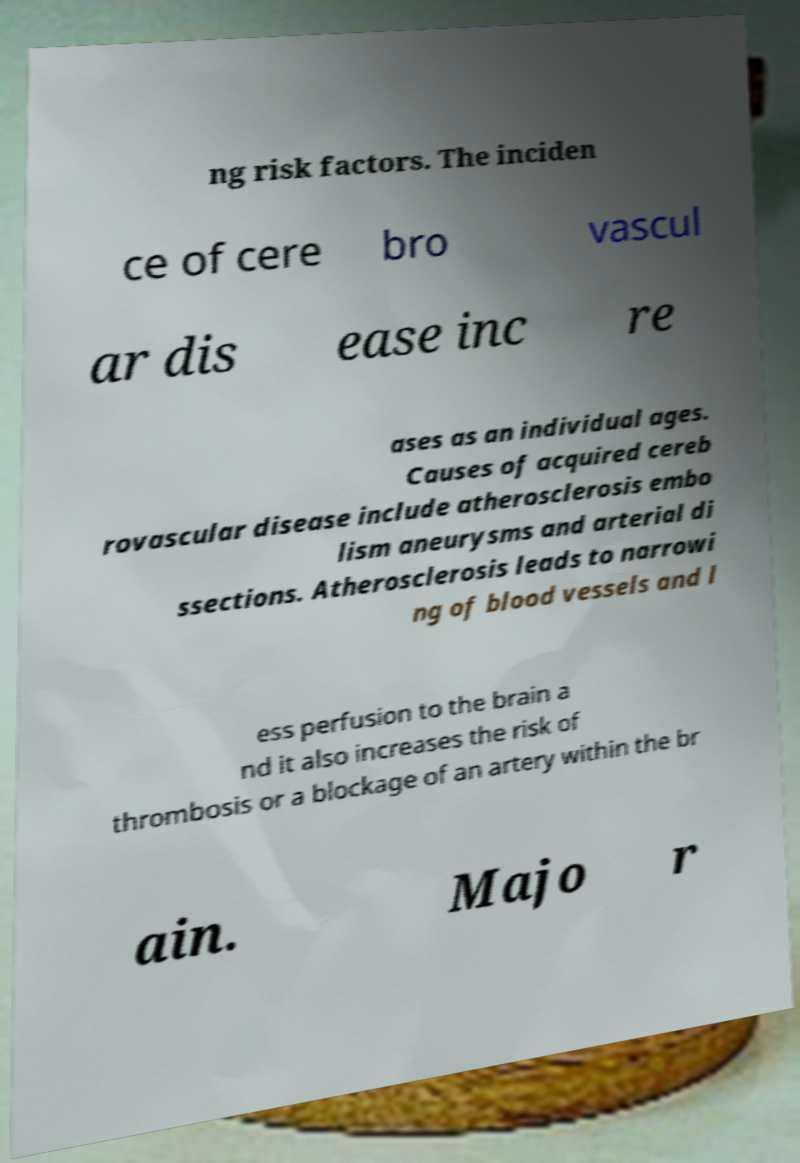Could you extract and type out the text from this image? ng risk factors. The inciden ce of cere bro vascul ar dis ease inc re ases as an individual ages. Causes of acquired cereb rovascular disease include atherosclerosis embo lism aneurysms and arterial di ssections. Atherosclerosis leads to narrowi ng of blood vessels and l ess perfusion to the brain a nd it also increases the risk of thrombosis or a blockage of an artery within the br ain. Majo r 